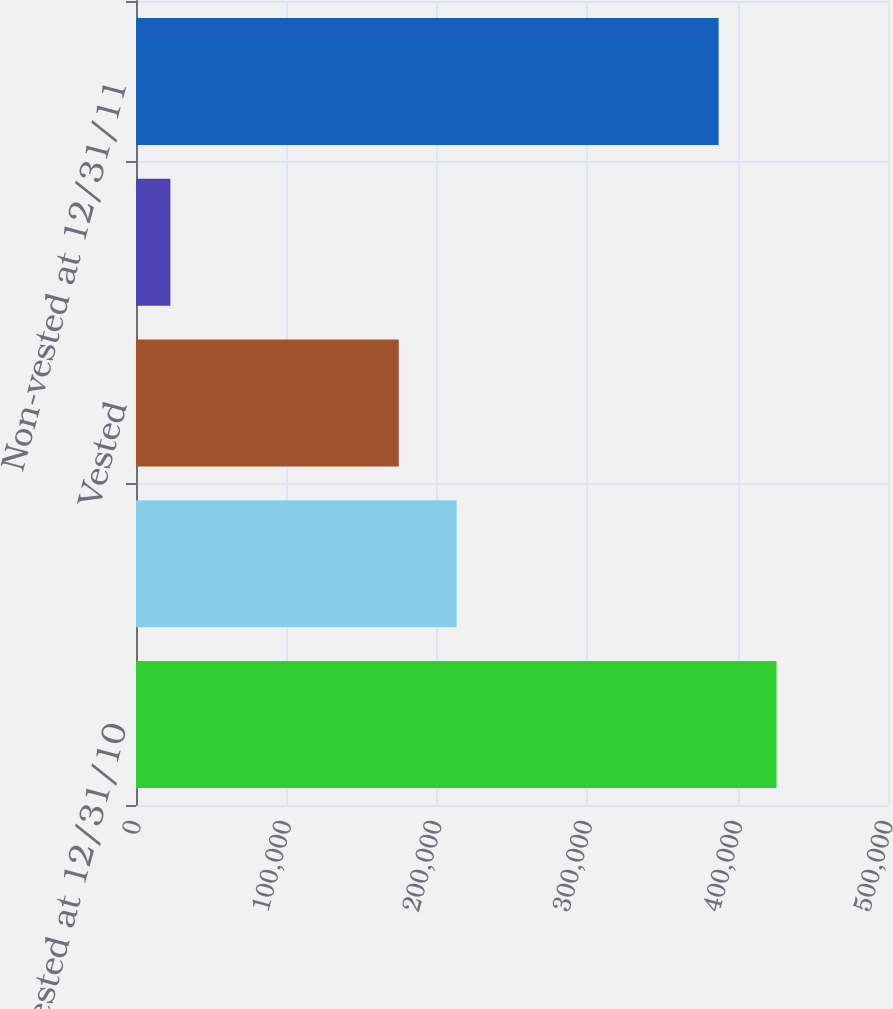Convert chart. <chart><loc_0><loc_0><loc_500><loc_500><bar_chart><fcel>Non-vested at 12/31/10<fcel>Granted<fcel>Vested<fcel>Forfeited<fcel>Non-vested at 12/31/11<nl><fcel>425880<fcel>213213<fcel>174712<fcel>22847<fcel>387379<nl></chart> 